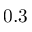Convert formula to latex. <formula><loc_0><loc_0><loc_500><loc_500>0 . 3</formula> 